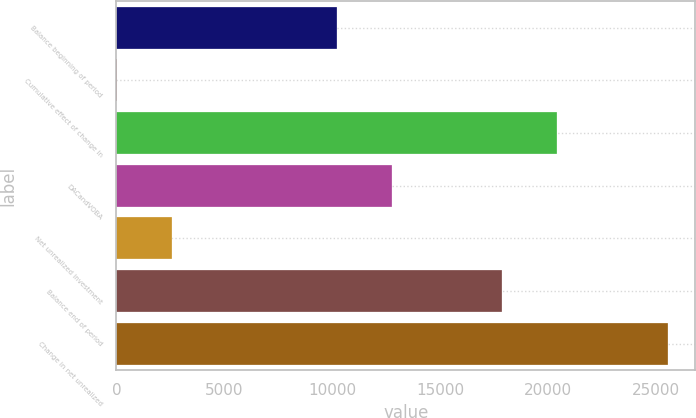Convert chart to OTSL. <chart><loc_0><loc_0><loc_500><loc_500><bar_chart><fcel>Balance beginning of period<fcel>Cumulative effect of change in<fcel>Unnamed: 2<fcel>DACandVOBA<fcel>Net unrealized investment<fcel>Balance end of period<fcel>Change in net unrealized<nl><fcel>10220.4<fcel>10<fcel>20430.8<fcel>12773<fcel>2562.6<fcel>17878.2<fcel>25536<nl></chart> 